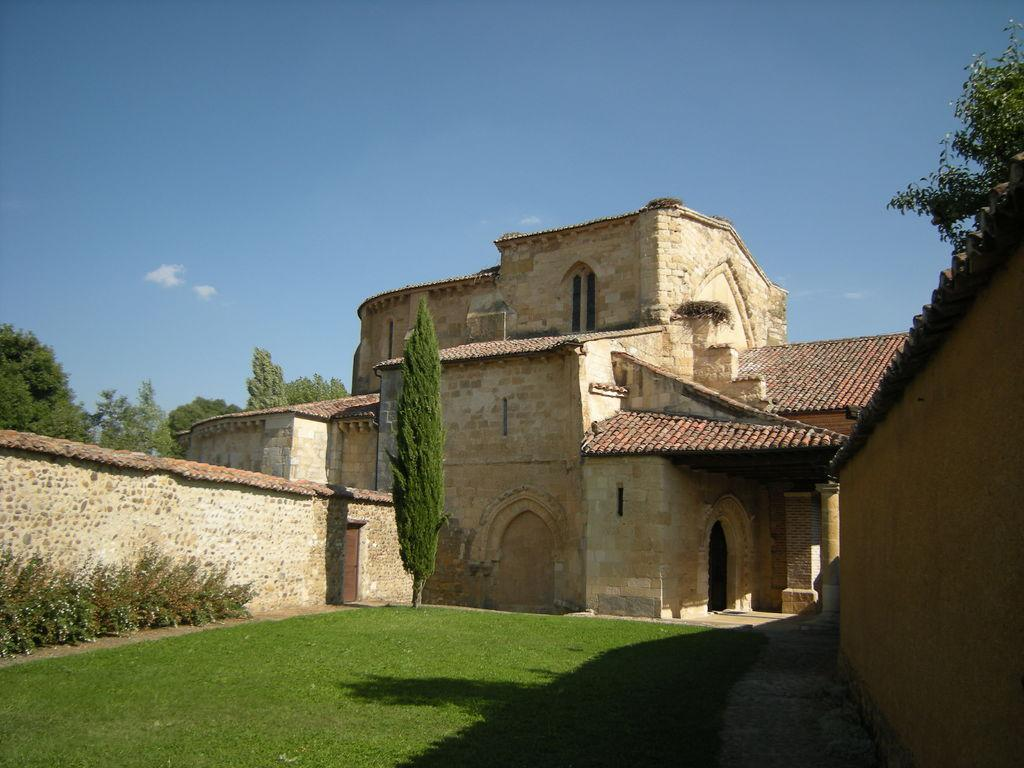What type of vegetation can be seen in the image? There is grass and plants in the image. What structures are visible in the image? There is a compound wall and a building in the image. What other natural elements can be seen in the image? There are trees in the image. What part of the natural environment is visible in the image? The sky is visible in the image. Where is the bell located in the image? There is no bell present in the image. What color is the heart in the image? There is no heart present in the image. 